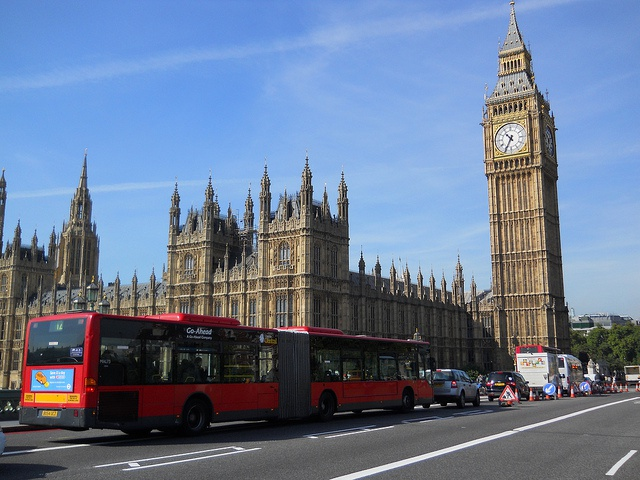Describe the objects in this image and their specific colors. I can see bus in gray, black, maroon, and red tones, car in gray, black, and blue tones, bus in gray, lightgray, darkgray, and black tones, car in gray, black, and maroon tones, and clock in gray, lightgray, and darkgray tones in this image. 